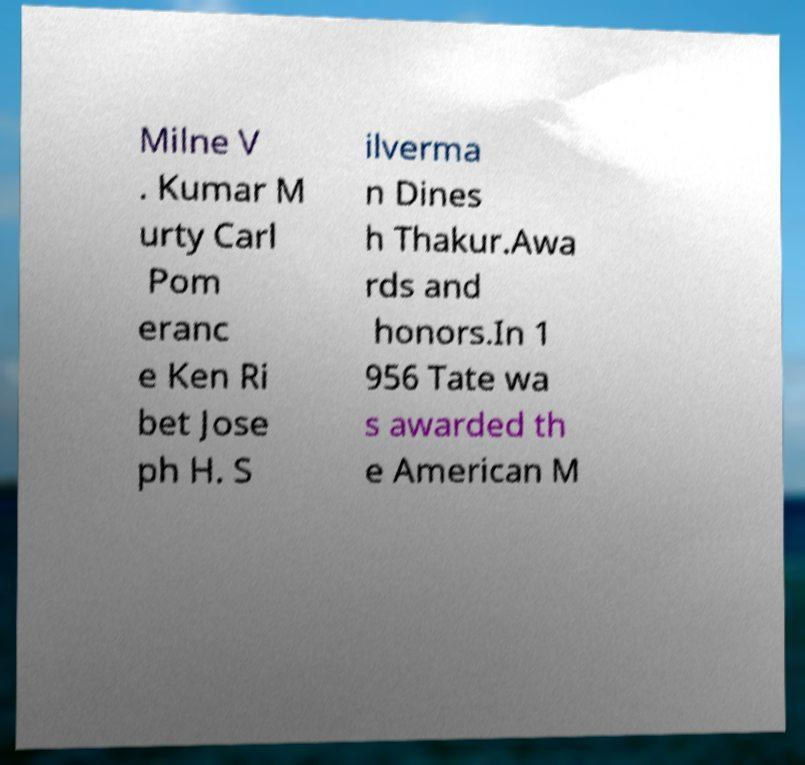Can you accurately transcribe the text from the provided image for me? Milne V . Kumar M urty Carl Pom eranc e Ken Ri bet Jose ph H. S ilverma n Dines h Thakur.Awa rds and honors.In 1 956 Tate wa s awarded th e American M 